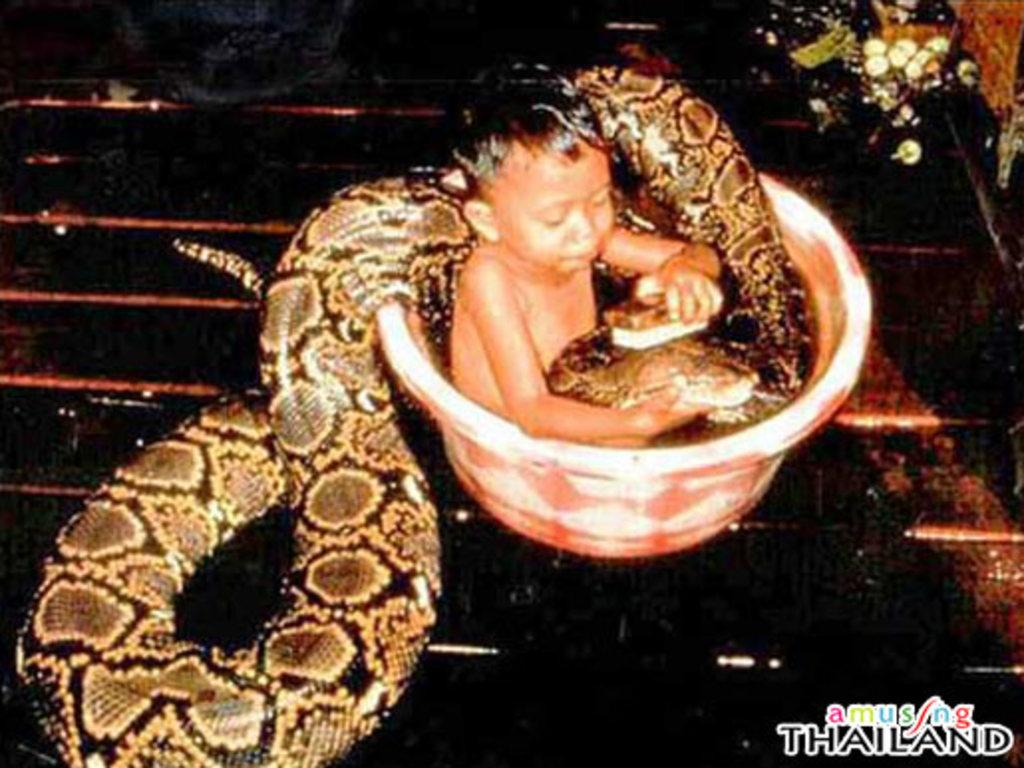What is the kid doing in the image? The kid is sitting in a tub. What other object or creature is present in the image? There is a snake in the image. Is there any text or writing in the image? Yes, there is text in the bottom right corner of the image. What type of spoon is the yak holding in the image? There is no yak or spoon present in the image. 